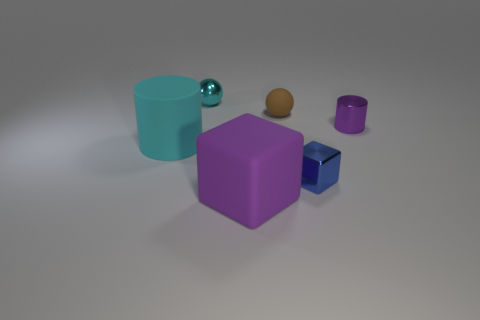Add 3 big gray matte things. How many objects exist? 9 Subtract all blue cubes. How many cubes are left? 1 Subtract all cubes. How many objects are left? 4 Subtract 1 balls. How many balls are left? 1 Subtract all cyan balls. Subtract all tiny spheres. How many objects are left? 3 Add 1 cylinders. How many cylinders are left? 3 Add 2 blue metal things. How many blue metal things exist? 3 Subtract 0 gray cubes. How many objects are left? 6 Subtract all red cylinders. Subtract all green spheres. How many cylinders are left? 2 Subtract all blue cylinders. How many yellow balls are left? 0 